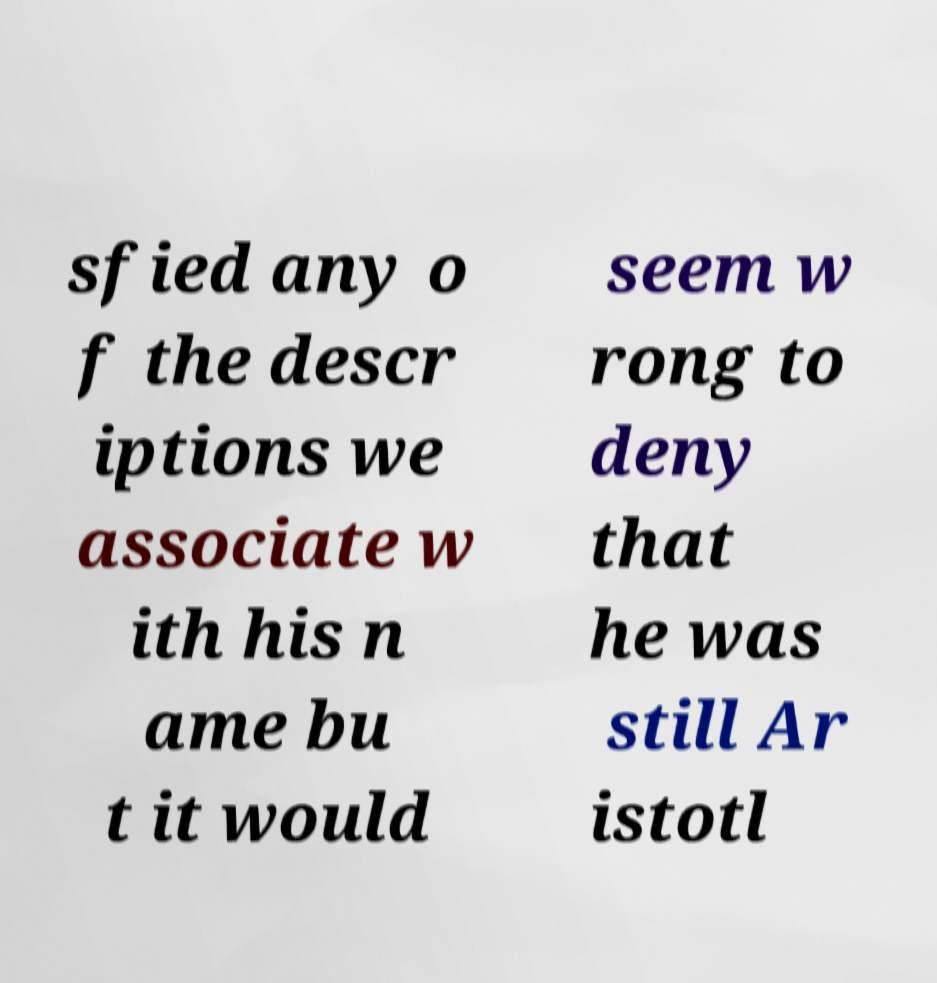Can you read and provide the text displayed in the image?This photo seems to have some interesting text. Can you extract and type it out for me? sfied any o f the descr iptions we associate w ith his n ame bu t it would seem w rong to deny that he was still Ar istotl 